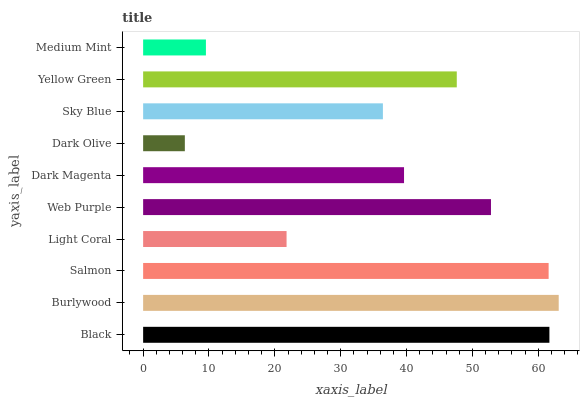Is Dark Olive the minimum?
Answer yes or no. Yes. Is Burlywood the maximum?
Answer yes or no. Yes. Is Salmon the minimum?
Answer yes or no. No. Is Salmon the maximum?
Answer yes or no. No. Is Burlywood greater than Salmon?
Answer yes or no. Yes. Is Salmon less than Burlywood?
Answer yes or no. Yes. Is Salmon greater than Burlywood?
Answer yes or no. No. Is Burlywood less than Salmon?
Answer yes or no. No. Is Yellow Green the high median?
Answer yes or no. Yes. Is Dark Magenta the low median?
Answer yes or no. Yes. Is Burlywood the high median?
Answer yes or no. No. Is Burlywood the low median?
Answer yes or no. No. 